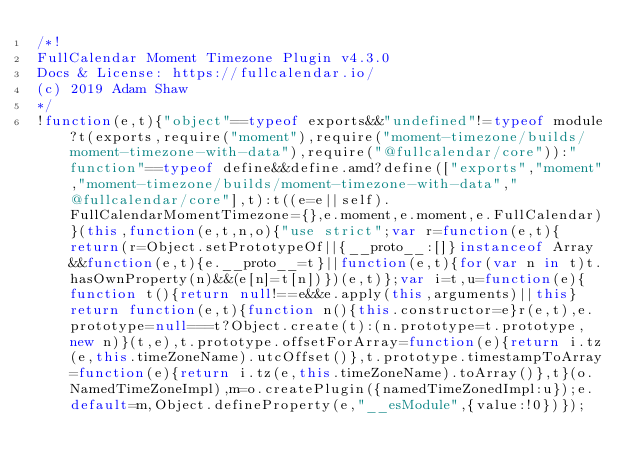<code> <loc_0><loc_0><loc_500><loc_500><_JavaScript_>/*!
FullCalendar Moment Timezone Plugin v4.3.0
Docs & License: https://fullcalendar.io/
(c) 2019 Adam Shaw
*/
!function(e,t){"object"==typeof exports&&"undefined"!=typeof module?t(exports,require("moment"),require("moment-timezone/builds/moment-timezone-with-data"),require("@fullcalendar/core")):"function"==typeof define&&define.amd?define(["exports","moment","moment-timezone/builds/moment-timezone-with-data","@fullcalendar/core"],t):t((e=e||self).FullCalendarMomentTimezone={},e.moment,e.moment,e.FullCalendar)}(this,function(e,t,n,o){"use strict";var r=function(e,t){return(r=Object.setPrototypeOf||{__proto__:[]}instanceof Array&&function(e,t){e.__proto__=t}||function(e,t){for(var n in t)t.hasOwnProperty(n)&&(e[n]=t[n])})(e,t)};var i=t,u=function(e){function t(){return null!==e&&e.apply(this,arguments)||this}return function(e,t){function n(){this.constructor=e}r(e,t),e.prototype=null===t?Object.create(t):(n.prototype=t.prototype,new n)}(t,e),t.prototype.offsetForArray=function(e){return i.tz(e,this.timeZoneName).utcOffset()},t.prototype.timestampToArray=function(e){return i.tz(e,this.timeZoneName).toArray()},t}(o.NamedTimeZoneImpl),m=o.createPlugin({namedTimeZonedImpl:u});e.default=m,Object.defineProperty(e,"__esModule",{value:!0})});</code> 